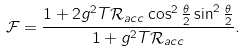Convert formula to latex. <formula><loc_0><loc_0><loc_500><loc_500>\mathcal { F } = \frac { 1 + 2 g ^ { 2 } T \mathcal { R } _ { a c c } \cos ^ { 2 } \frac { \theta } { 2 } \sin ^ { 2 } \frac { \theta } { 2 } } { 1 + g ^ { 2 } T \mathcal { R } _ { a c c } } .</formula> 